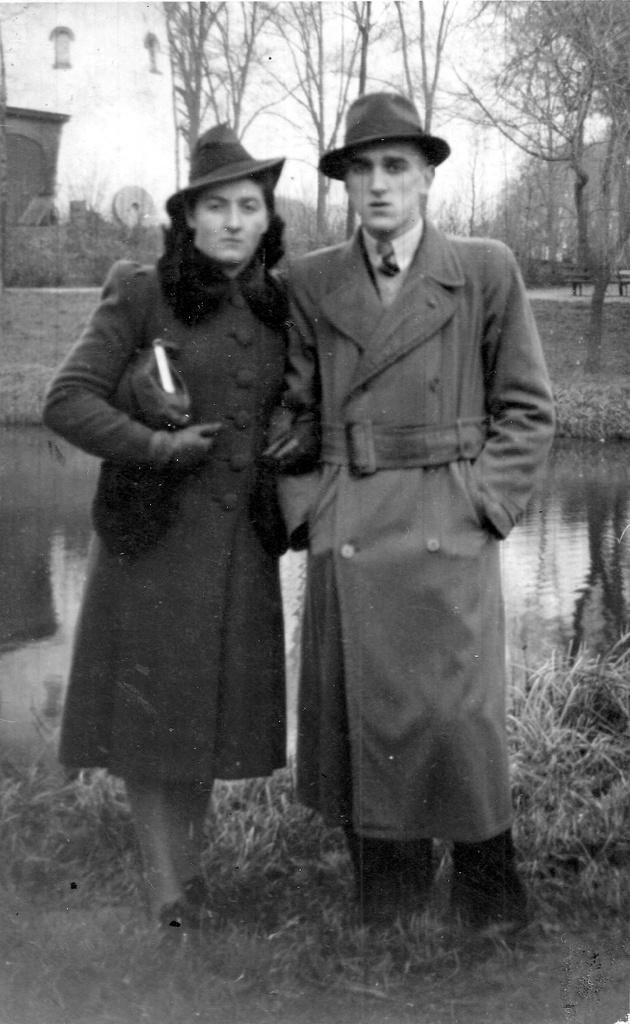How would you summarize this image in a sentence or two? In this picture we can see a man and a woman standing in the front, they wore caps, at the bottom there are some plants, we can see water in the middle, in the background there are some trees, a bench and a building, we can see the sky at the top of the picture, it is a black and white image. 